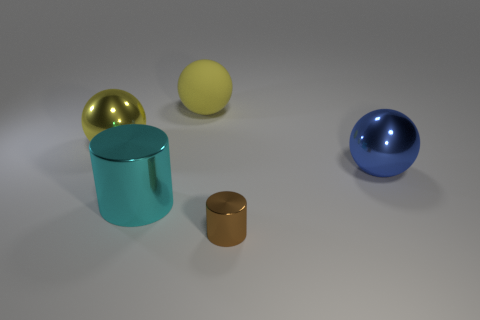There is a metallic object behind the big blue metal thing; is its shape the same as the tiny object?
Give a very brief answer. No. Are there any large green metallic cylinders?
Make the answer very short. No. There is a metal ball to the left of the large metal object on the right side of the yellow rubber sphere left of the tiny metal cylinder; what color is it?
Offer a very short reply. Yellow. Are there the same number of shiny cylinders that are behind the large blue metallic sphere and brown metallic things on the left side of the brown object?
Ensure brevity in your answer.  Yes. What is the shape of the other yellow thing that is the same size as the yellow shiny thing?
Your answer should be compact. Sphere. Is there a large shiny object of the same color as the big matte sphere?
Offer a terse response. Yes. What is the shape of the metal object that is behind the big blue sphere?
Give a very brief answer. Sphere. The large rubber object has what color?
Make the answer very short. Yellow. There is another cylinder that is made of the same material as the large cyan cylinder; what is its color?
Your answer should be very brief. Brown. What number of large yellow spheres have the same material as the big cyan cylinder?
Your answer should be compact. 1. 